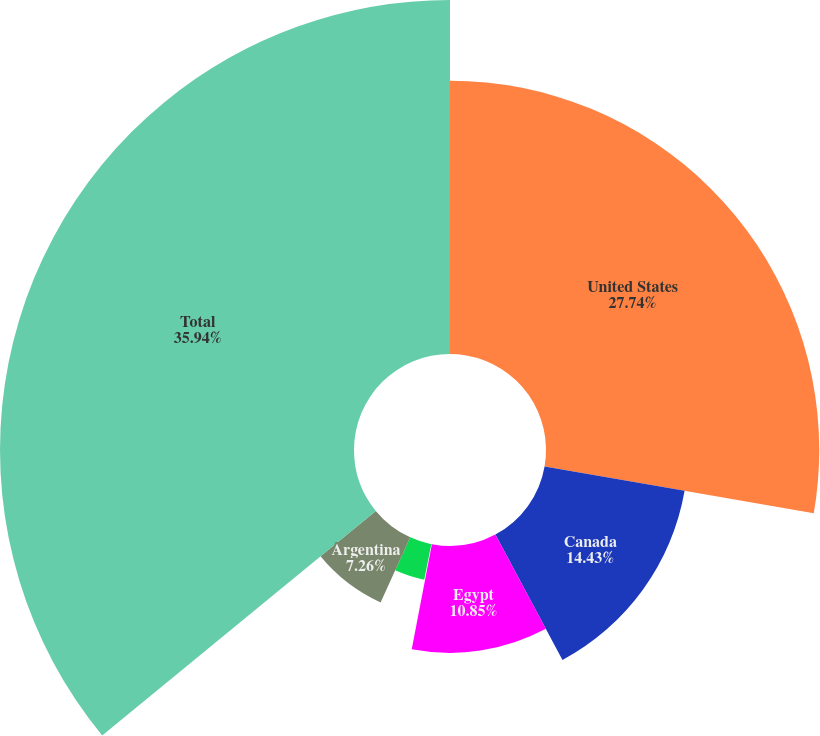Convert chart to OTSL. <chart><loc_0><loc_0><loc_500><loc_500><pie_chart><fcel>United States<fcel>Canada<fcel>Egypt<fcel>Australia<fcel>North Sea<fcel>Argentina<fcel>Total<nl><fcel>27.74%<fcel>14.43%<fcel>10.85%<fcel>0.1%<fcel>3.68%<fcel>7.26%<fcel>35.94%<nl></chart> 